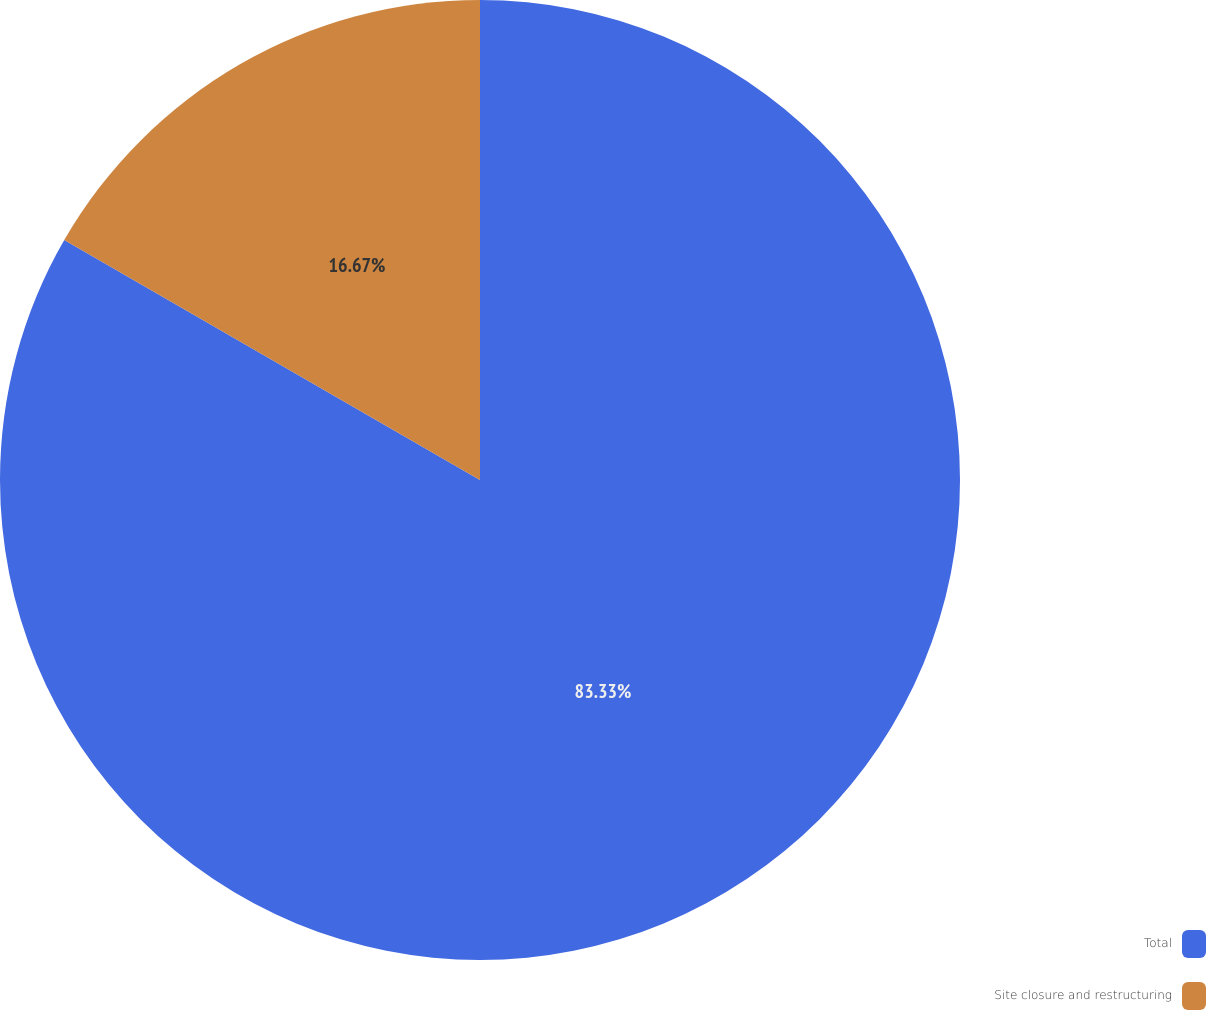Convert chart. <chart><loc_0><loc_0><loc_500><loc_500><pie_chart><fcel>Total<fcel>Site closure and restructuring<nl><fcel>83.33%<fcel>16.67%<nl></chart> 